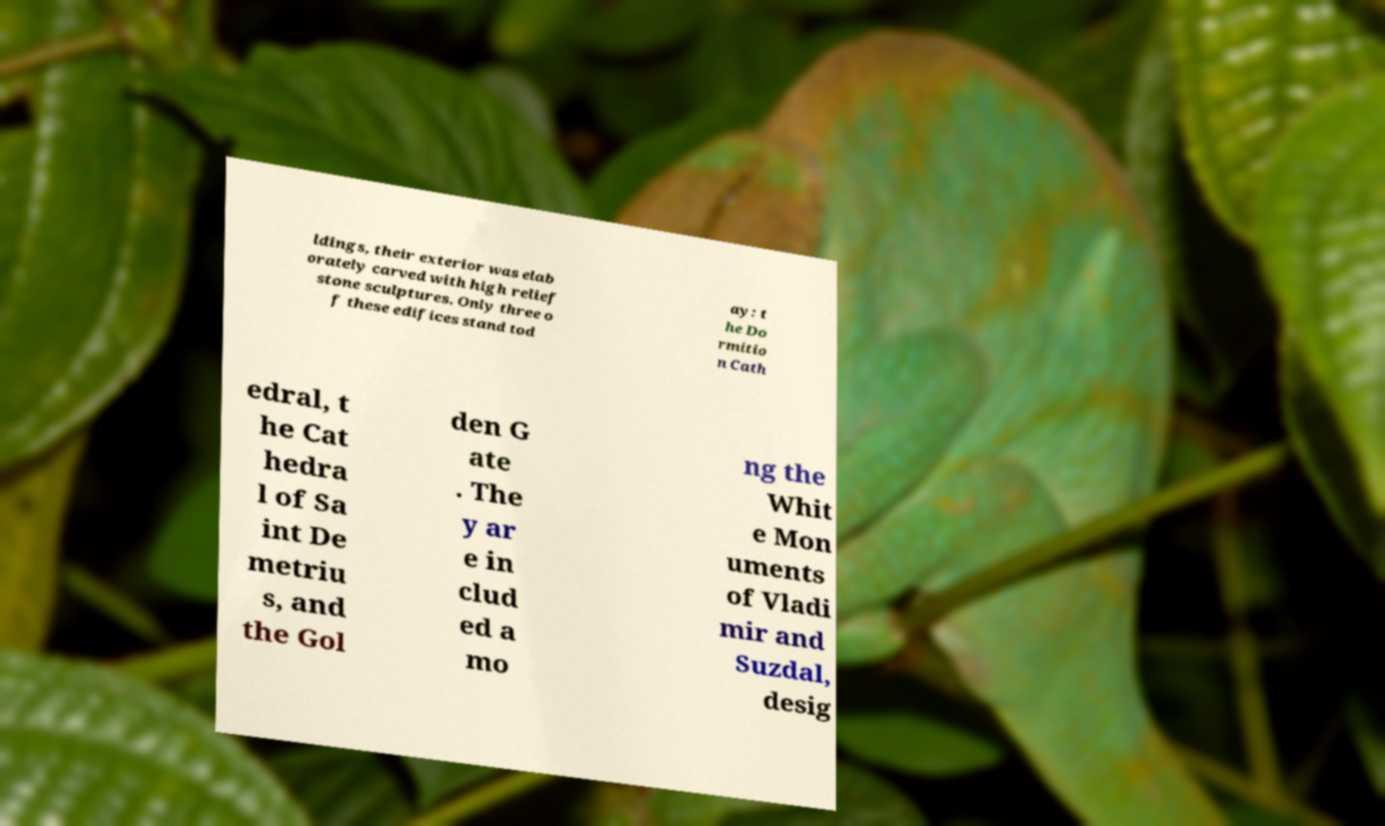Can you accurately transcribe the text from the provided image for me? ldings, their exterior was elab orately carved with high relief stone sculptures. Only three o f these edifices stand tod ay: t he Do rmitio n Cath edral, t he Cat hedra l of Sa int De metriu s, and the Gol den G ate . The y ar e in clud ed a mo ng the Whit e Mon uments of Vladi mir and Suzdal, desig 